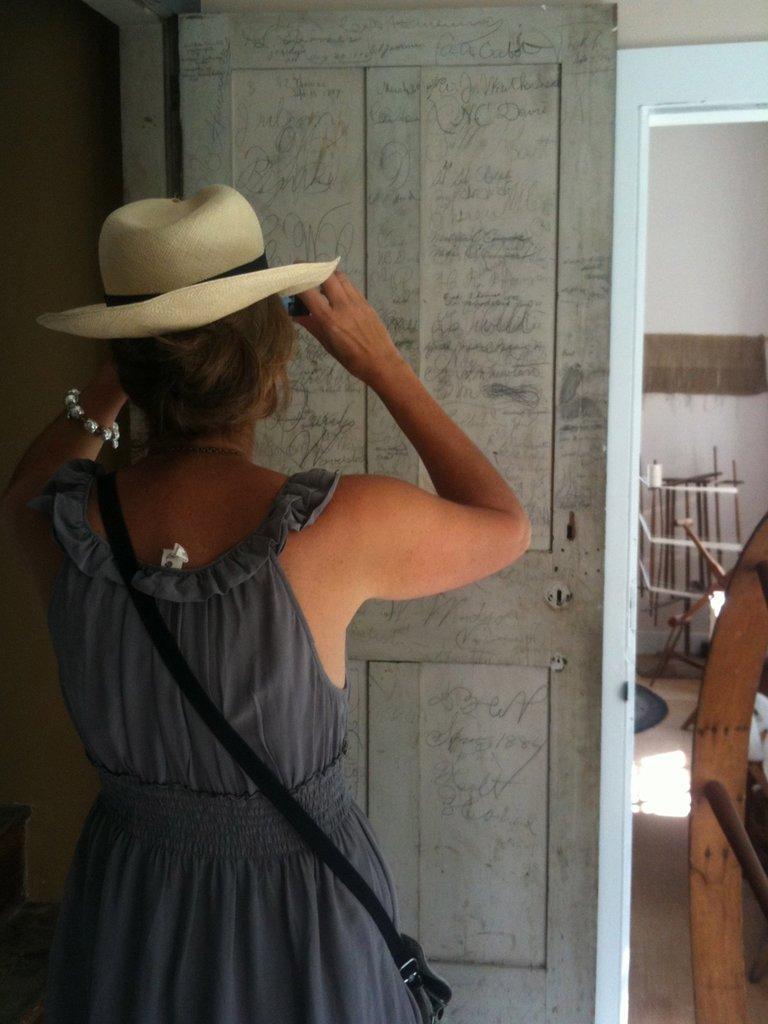In one or two sentences, can you explain what this image depicts? In this image we can see a person standing and wearing a hat. Behind the person we can see a door with text on it. On the right side of the image we can see a mirror and in the mirror, we can see the reflection of few objects and a wall. 